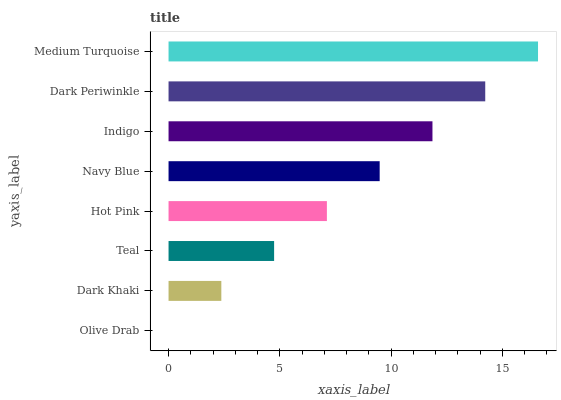Is Olive Drab the minimum?
Answer yes or no. Yes. Is Medium Turquoise the maximum?
Answer yes or no. Yes. Is Dark Khaki the minimum?
Answer yes or no. No. Is Dark Khaki the maximum?
Answer yes or no. No. Is Dark Khaki greater than Olive Drab?
Answer yes or no. Yes. Is Olive Drab less than Dark Khaki?
Answer yes or no. Yes. Is Olive Drab greater than Dark Khaki?
Answer yes or no. No. Is Dark Khaki less than Olive Drab?
Answer yes or no. No. Is Navy Blue the high median?
Answer yes or no. Yes. Is Hot Pink the low median?
Answer yes or no. Yes. Is Dark Khaki the high median?
Answer yes or no. No. Is Olive Drab the low median?
Answer yes or no. No. 